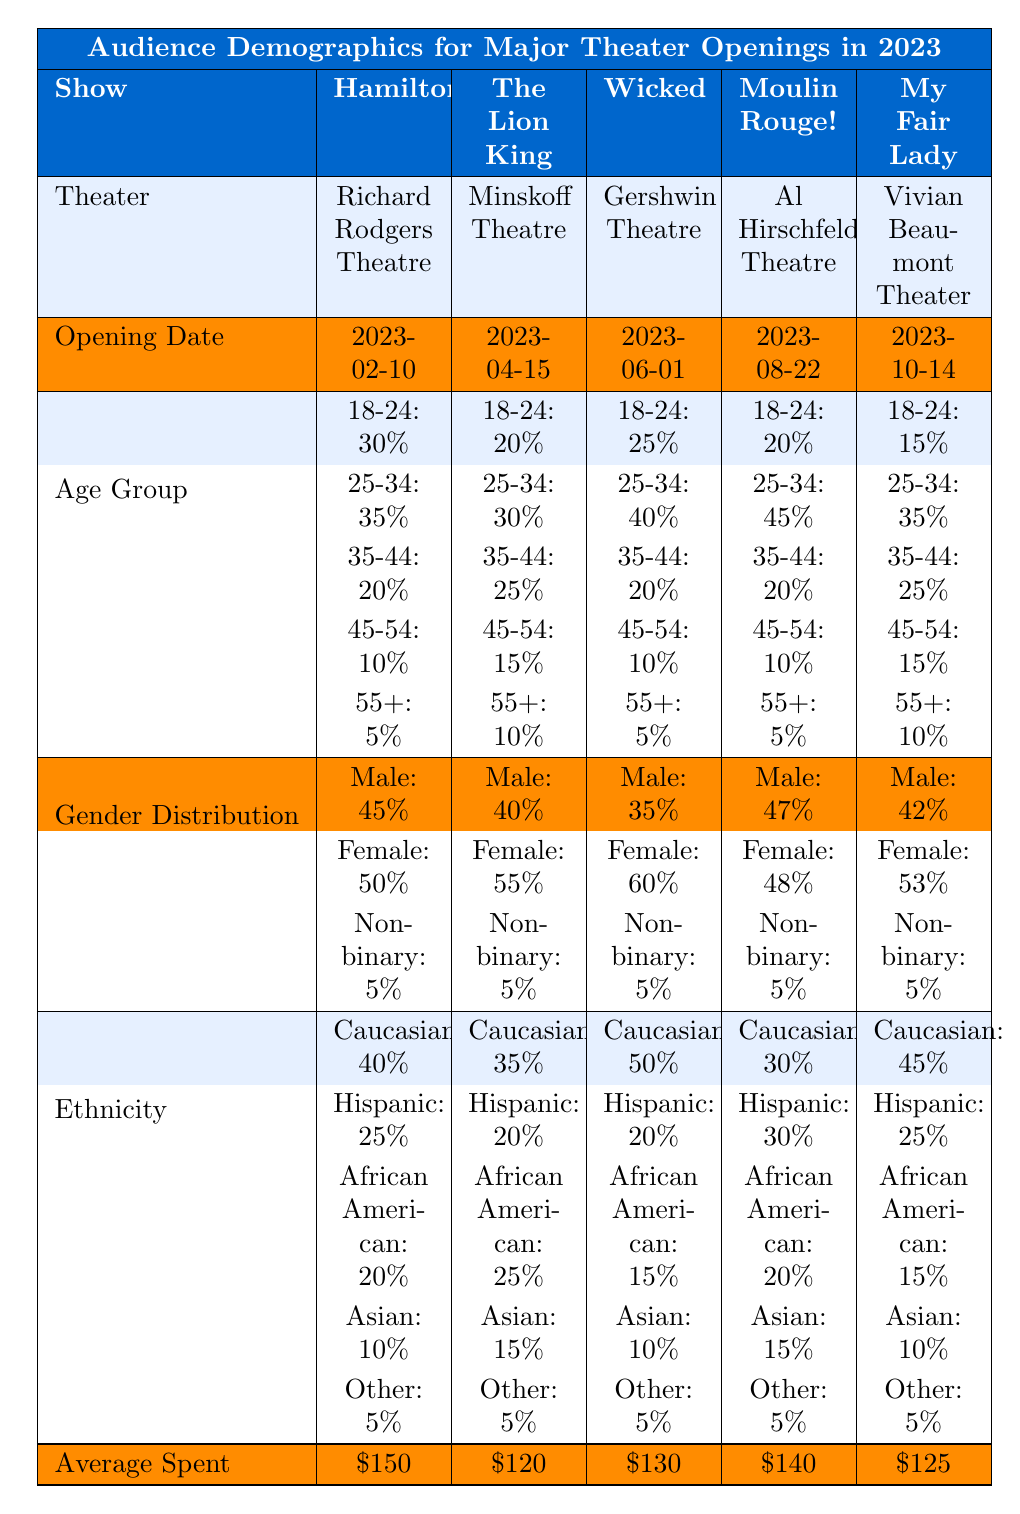What is the average spent by audience members for "Wicked"? The average spent for "Wicked" is listed directly in the table under its respective column, which shows \$130.
Answer: \$130 Which show had the highest percentage of male audience members? Comparing the gender distribution across all shows, "Moulin Rouge!" has the highest percentage of male audience members at 47%.
Answer: 47% What is the ethnic distribution of the audience for "The Lion King"? The table provides the ethnic distribution for "The Lion King": Caucasian: 35%, Hispanic: 20%, African American: 25%, Asian: 15%, Other: 5%.
Answer: Caucasian: 35%, Hispanic: 20%, African American: 25%, Asian: 15%, Other: 5% Which age group had the lowest percentage in "My Fair Lady"? Looking at the age group distribution for "My Fair Lady," the 18-24 age group had the lowest percentage at 15%.
Answer: 15% What is the total percentage of the audience aged 35-44 for all the shows combined? To find the total percentage of the 35-44 age group, we sum the percentages from all shows: 20% (Hamilton) + 25% (The Lion King) + 20% (Wicked) + 20% (Moulin Rouge!) + 25% (My Fair Lady) = 110%.
Answer: 110% Is the average spending higher for "Hamilton" compared to "My Fair Lady"? Comparing the average spending, "Hamilton" has \$150, while "My Fair Lady" has \$125. Since \$150 is greater than \$125, the statement is true.
Answer: Yes What percentage of the audience for "Wicked" is non-binary? The gender distribution for "Wicked" shows that 5% of its audience identifies as non-binary, which is a direct retrieval from the table.
Answer: 5% Which show has the largest audience segment in the 25-34 age group? The percentage for the 25-34 age group is highest for "Moulin Rouge!" at 45%, compared to the other shows' percentages. This can be seen directly in the age group breakdown.
Answer: 45% What is the average percentage of Hispanic audience members across all shows? To find the average percentage of Hispanic audience members, we sum the percentages from each show: 25% (Hamilton) + 20% (The Lion King) + 20% (Wicked) + 30% (Moulin Rouge!) + 25% (My Fair Lady) = 120%. There are 5 shows, so we divide 120% by 5, resulting in an average of 24%.
Answer: 24% True or False: The audience for "Moulin Rouge!" spent more on average than the audience for "The Lion King." The average spending for "Moulin Rouge!" is \$140, while for "The Lion King" it is \$120. Since \$140 is greater than \$120, the statement is true.
Answer: True 